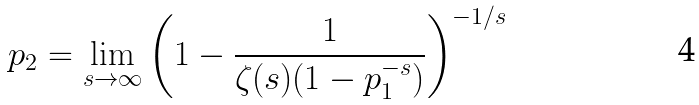<formula> <loc_0><loc_0><loc_500><loc_500>p _ { 2 } = \lim _ { s \to \infty } \left ( 1 - \frac { 1 } { \zeta ( s ) ( 1 - p _ { 1 } ^ { - s } ) } \right ) ^ { - 1 / s }</formula> 